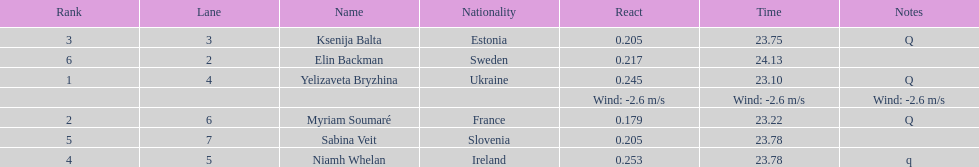Who is the first ranking player? Yelizaveta Bryzhina. 